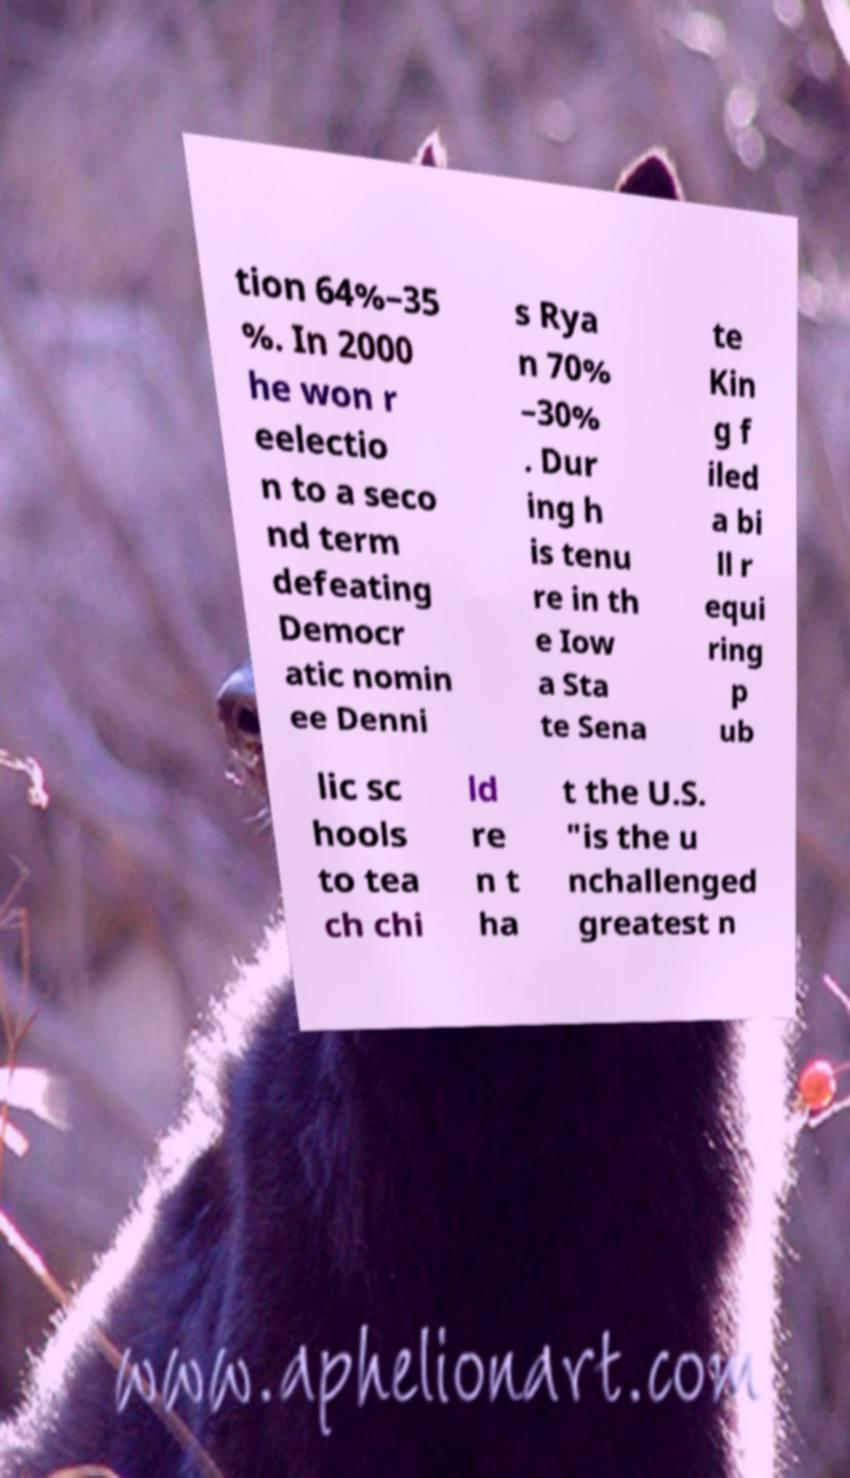Can you accurately transcribe the text from the provided image for me? tion 64%–35 %. In 2000 he won r eelectio n to a seco nd term defeating Democr atic nomin ee Denni s Rya n 70% –30% . Dur ing h is tenu re in th e Iow a Sta te Sena te Kin g f iled a bi ll r equi ring p ub lic sc hools to tea ch chi ld re n t ha t the U.S. "is the u nchallenged greatest n 